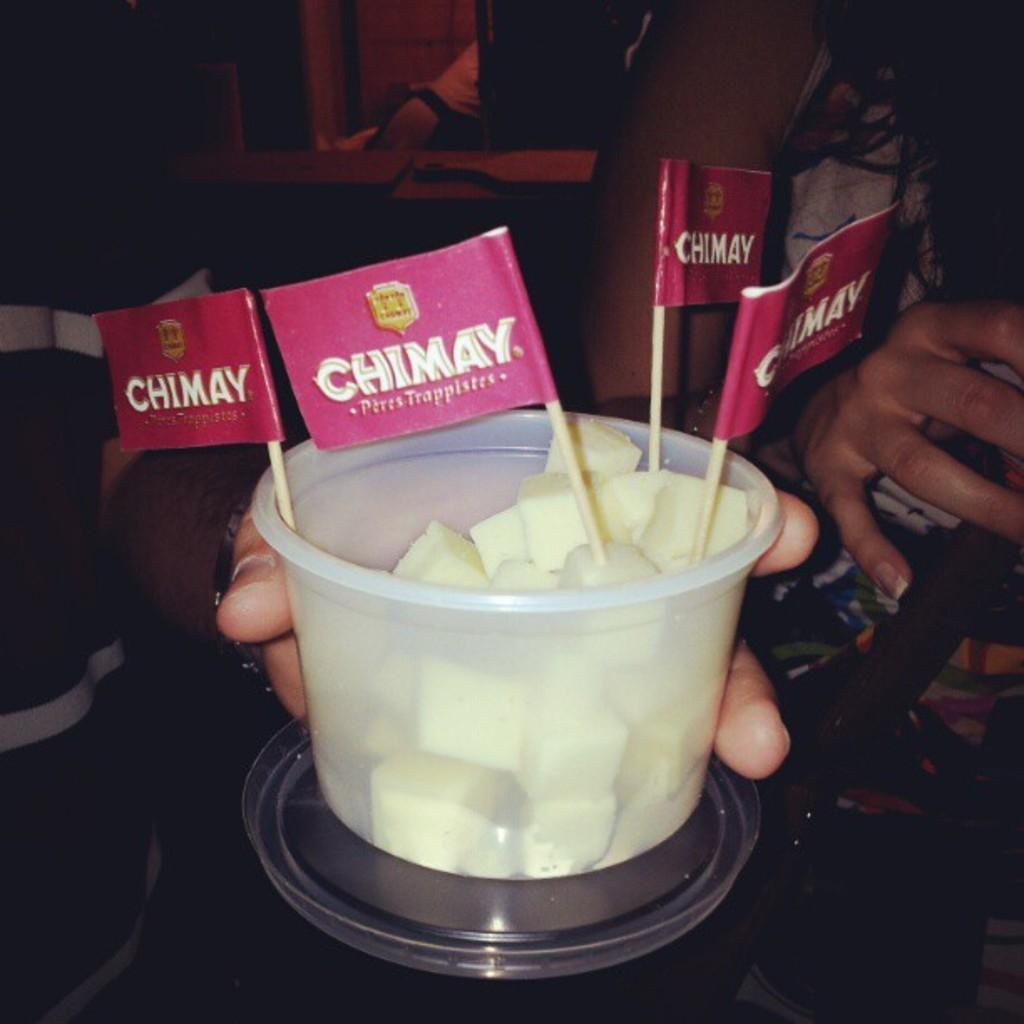What is the person in the image holding? The person is holding a cup in the image. What is inside the cup? The cup contains food. Are there any additional items in the cup? Yes, there are flags in the cup. Can you describe the person on the right side of the image? There is a woman on the right side of the image. What type of trains can be seen in the heart of the image? There are no trains or hearts present in the image; it features a person holding a cup with food and flags. 